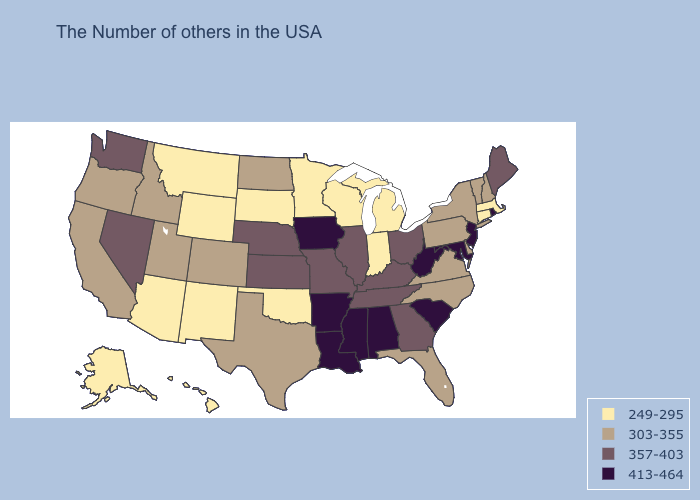Name the states that have a value in the range 249-295?
Short answer required. Massachusetts, Connecticut, Michigan, Indiana, Wisconsin, Minnesota, Oklahoma, South Dakota, Wyoming, New Mexico, Montana, Arizona, Alaska, Hawaii. Does North Dakota have a higher value than Massachusetts?
Keep it brief. Yes. Name the states that have a value in the range 357-403?
Write a very short answer. Maine, Ohio, Georgia, Kentucky, Tennessee, Illinois, Missouri, Kansas, Nebraska, Nevada, Washington. Does the map have missing data?
Short answer required. No. What is the value of Delaware?
Write a very short answer. 303-355. Name the states that have a value in the range 357-403?
Keep it brief. Maine, Ohio, Georgia, Kentucky, Tennessee, Illinois, Missouri, Kansas, Nebraska, Nevada, Washington. What is the value of West Virginia?
Short answer required. 413-464. Does Iowa have the same value as Mississippi?
Concise answer only. Yes. Name the states that have a value in the range 357-403?
Short answer required. Maine, Ohio, Georgia, Kentucky, Tennessee, Illinois, Missouri, Kansas, Nebraska, Nevada, Washington. Does Indiana have a higher value than California?
Quick response, please. No. Does Minnesota have the highest value in the USA?
Quick response, please. No. What is the highest value in the USA?
Give a very brief answer. 413-464. Name the states that have a value in the range 413-464?
Be succinct. Rhode Island, New Jersey, Maryland, South Carolina, West Virginia, Alabama, Mississippi, Louisiana, Arkansas, Iowa. What is the value of Ohio?
Give a very brief answer. 357-403. Is the legend a continuous bar?
Write a very short answer. No. 